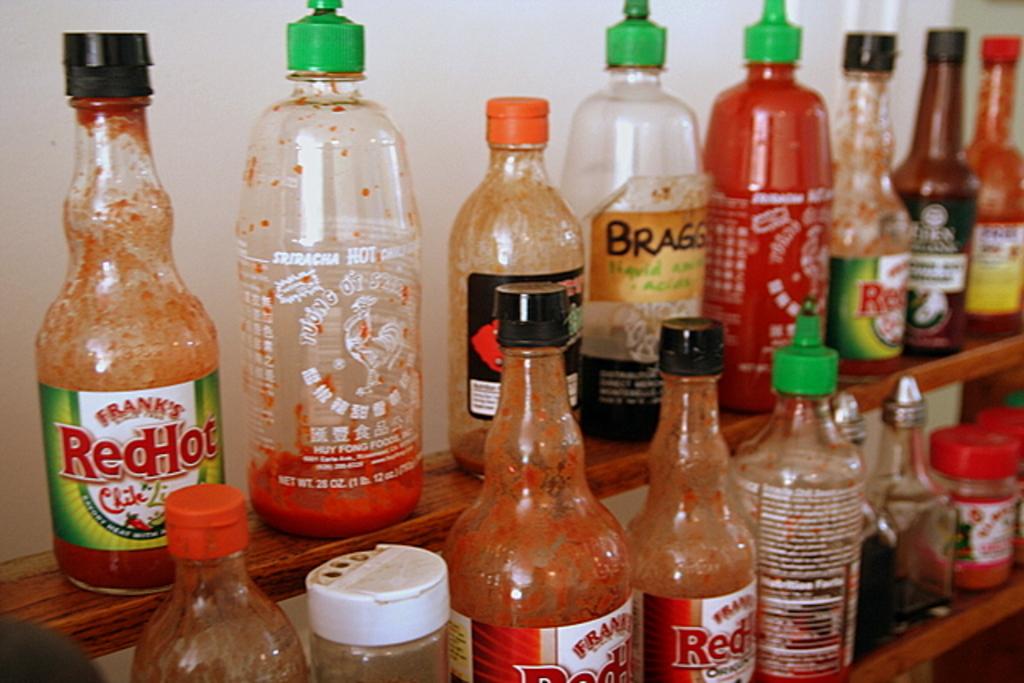What type of sauce is in the bottle with a green cap?
Your answer should be compact. Sriracha. 